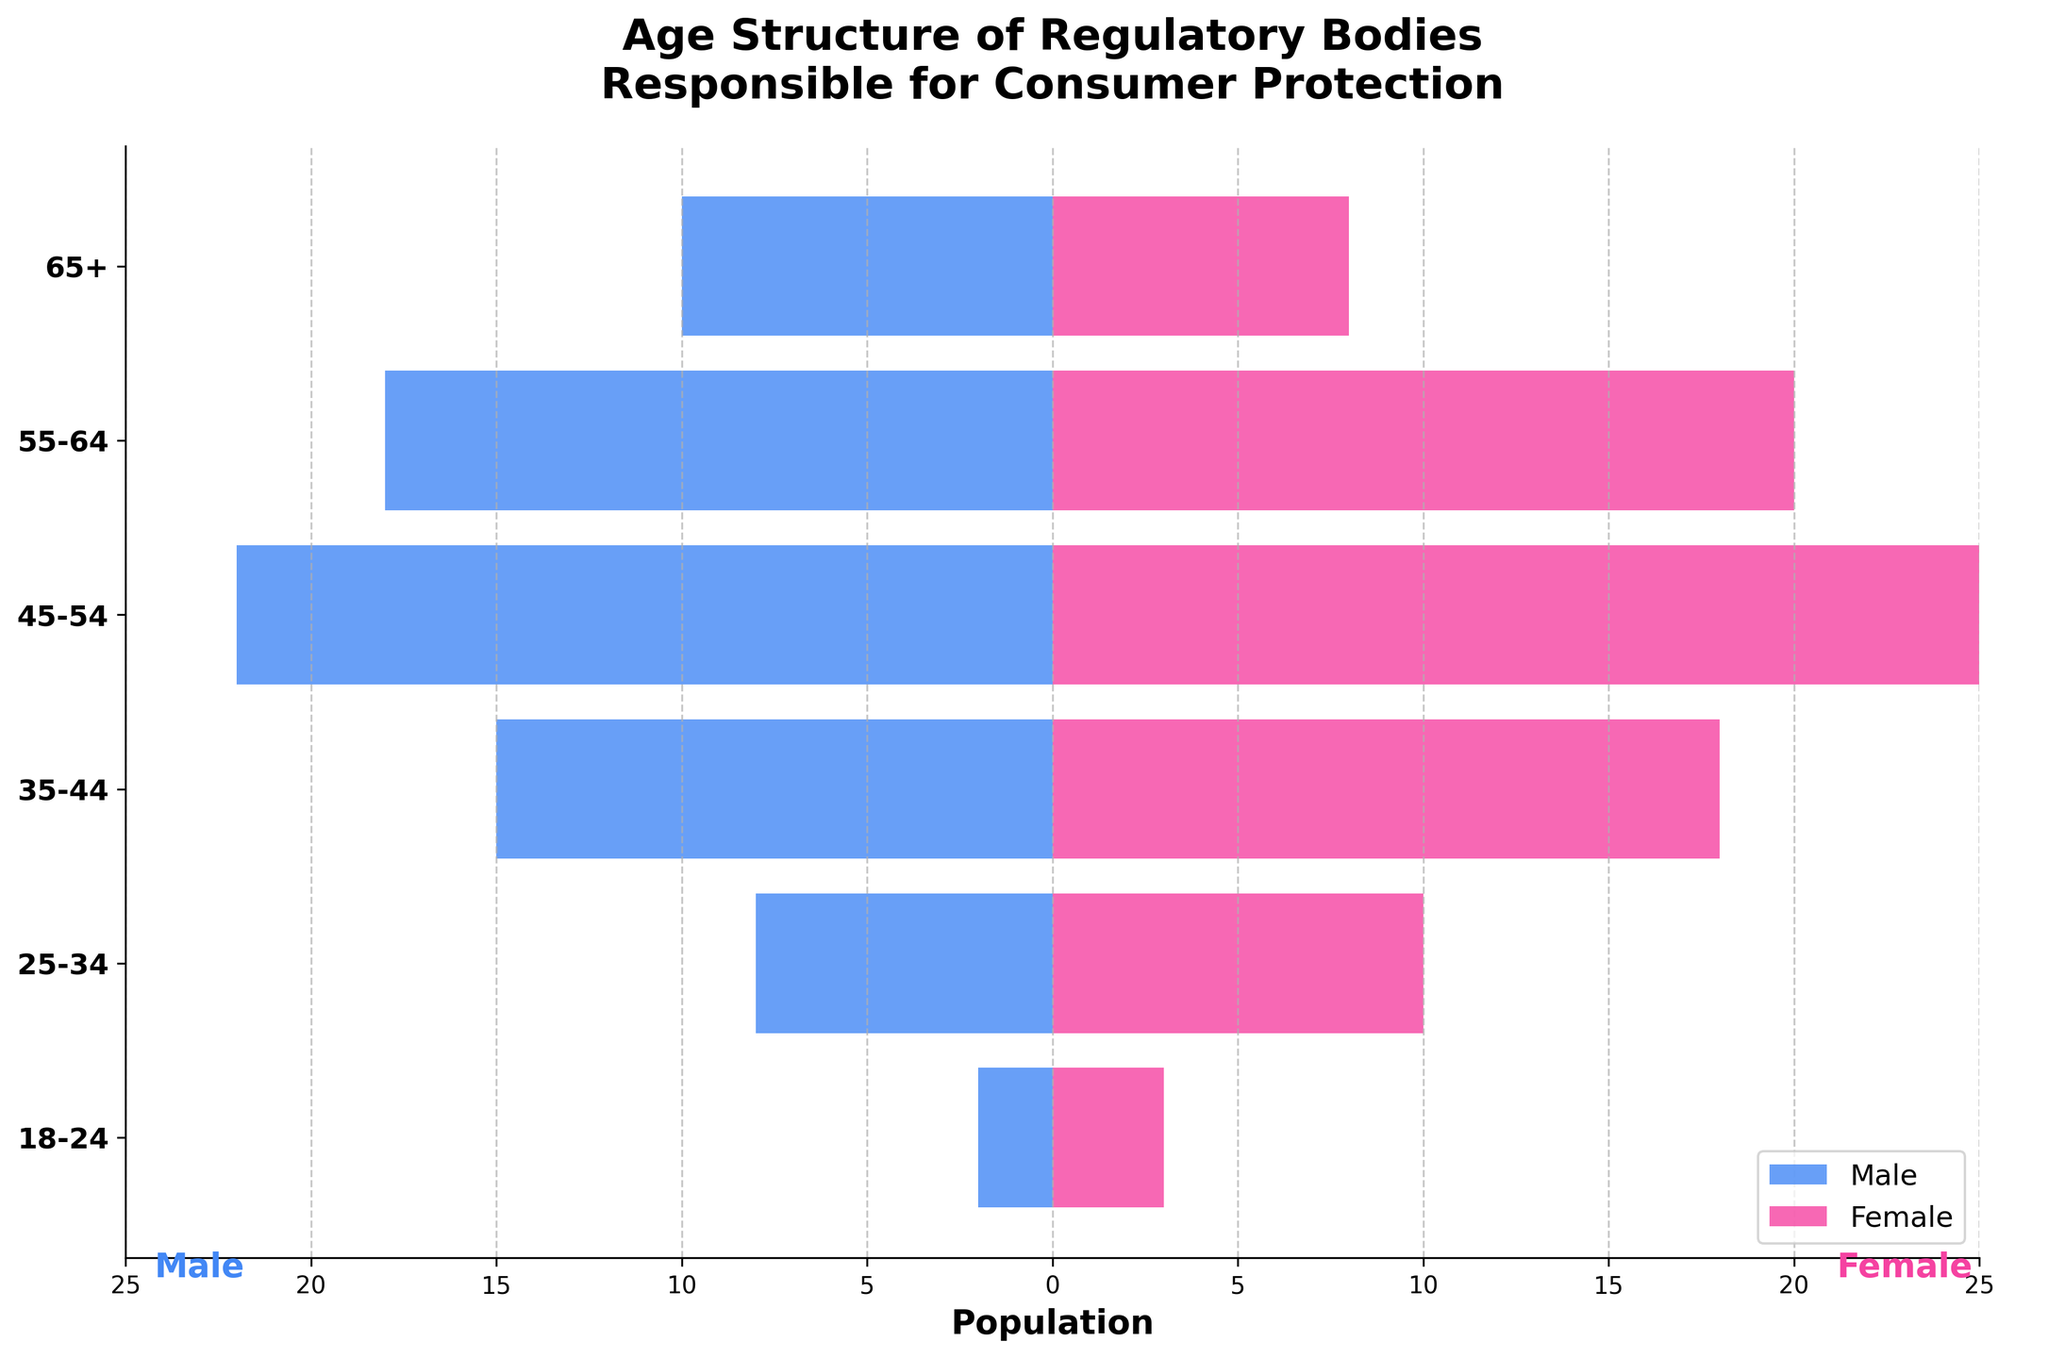Which age group has the highest population of females? The age group 45-54 has the highest number of females, with 25 individuals. This can be seen as the longest pink bar on the right side for females.
Answer: 45-54 Which gender has more people in the 65+ age category? In the 65+ age group, there are more males (10) compared to females (8). This can be seen by comparing the lengths of the blue and pink bars corresponding to this age group.
Answer: Male How many males and females are there in the 55-64 age category combined? There are 18 males and 20 females in the 55-64 age group. Summing these gives us 38.
Answer: 38 Which age group has the least population combined and what is the combined number? The 18-24 age group has the least combined population. Summing 2 males and 3 females gives us 5.
Answer: 5 What is the total number of males across all age groups? Adding up the male population across all age groups: 2 + 8 + 15 + 22 + 18 + 10 = 75.
Answer: 75 Which age group shows the largest imbalance between males and females? The age group 45-54 shows the largest imbalance with a difference of 3 (25 females - 22 males).
Answer: 45-54 How many more females than males are there in the 35-44 age group? In the 35-44 age group, there are 18 females and 15 males. The difference is 3 (18 - 15).
Answer: 3 What proportion of the total female population is in the 45-54 age group? First, find the total number of females: 3 + 10 + 18 + 25 + 20 + 8 = 84. The number of females in the 45-54 age group is 25. The proportion is 25/84, which is approximately 0.298 or 29.8%.
Answer: 29.8% Comparing the age groups 55-64 and 65+, which has a higher combined population, and by how much? The 55-64 age group has 18 males and 20 females (total of 38), while the 65+ group has 10 males and 8 females (total of 18). The difference is 38 - 18 = 20.
Answer: 55-64 by 20 Which age group has a total population closest to the median value among all age groups? The total populations are: 18-24: 5, 25-34: 18, 35-44: 33, 45-54: 47, 55-64: 38, 65+: 18. Ordering these gives us [5, 18, 18, 33, 38, 47]. The median is between 18 and 33, which is 25.5. The group 25-34, with a total of 18, is closest to this median value.
Answer: 25-34 